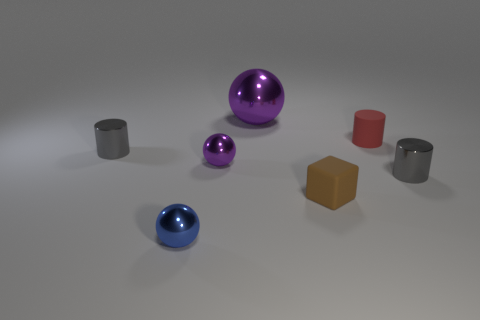What material is the tiny gray cylinder that is to the right of the purple shiny ball behind the tiny matte cylinder? The tiny gray cylinder to the right of the purple shiny ball, positioned behind the matte cylinder, appears to be made of a material with metallic properties, characterized by its reflective surface and gray color which is indicative of metals like steel or aluminum. 